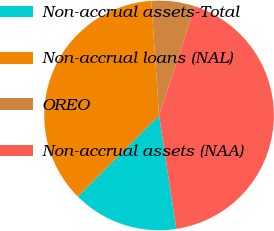Convert chart to OTSL. <chart><loc_0><loc_0><loc_500><loc_500><pie_chart><fcel>Non-accrual assets-Total<fcel>Non-accrual loans (NAL)<fcel>OREO<fcel>Non-accrual assets (NAA)<nl><fcel>14.91%<fcel>36.42%<fcel>6.13%<fcel>42.54%<nl></chart> 